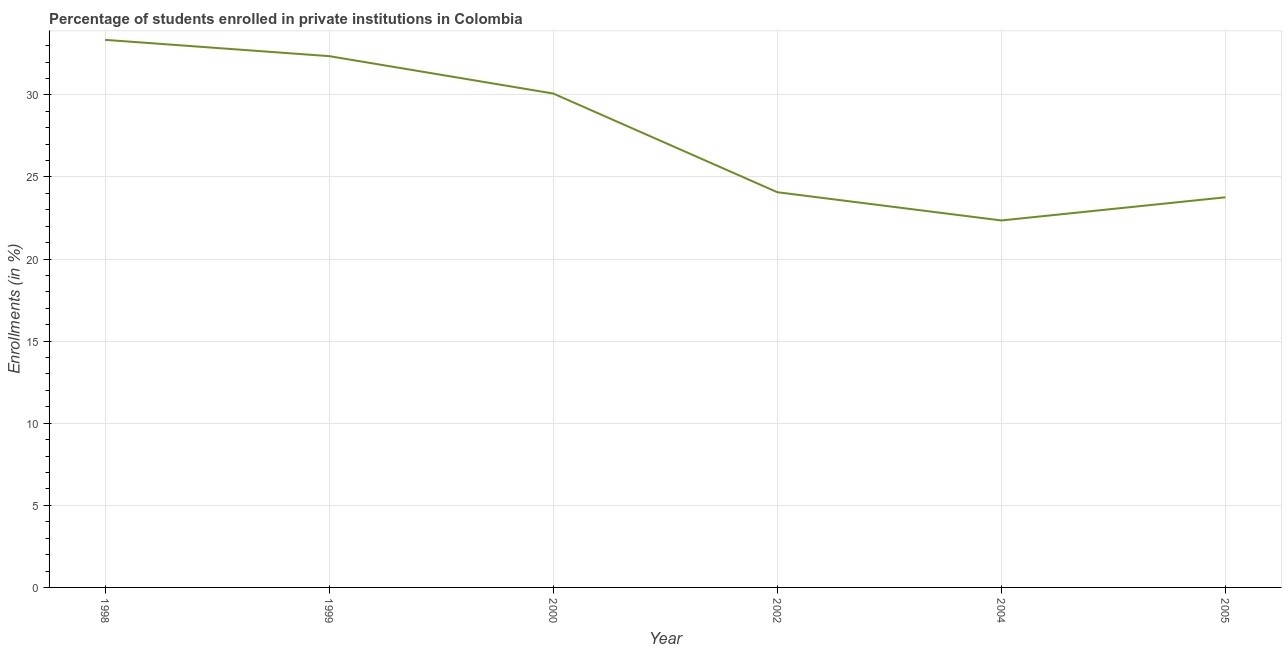What is the enrollments in private institutions in 2005?
Provide a succinct answer. 23.76. Across all years, what is the maximum enrollments in private institutions?
Your answer should be compact. 33.35. Across all years, what is the minimum enrollments in private institutions?
Offer a terse response. 22.35. In which year was the enrollments in private institutions maximum?
Make the answer very short. 1998. In which year was the enrollments in private institutions minimum?
Provide a short and direct response. 2004. What is the sum of the enrollments in private institutions?
Your answer should be compact. 165.98. What is the difference between the enrollments in private institutions in 2000 and 2005?
Provide a short and direct response. 6.32. What is the average enrollments in private institutions per year?
Offer a very short reply. 27.66. What is the median enrollments in private institutions?
Your answer should be compact. 27.08. What is the ratio of the enrollments in private institutions in 1998 to that in 2005?
Provide a succinct answer. 1.4. Is the enrollments in private institutions in 1998 less than that in 2000?
Your answer should be compact. No. What is the difference between the highest and the second highest enrollments in private institutions?
Provide a succinct answer. 0.99. Is the sum of the enrollments in private institutions in 1998 and 2005 greater than the maximum enrollments in private institutions across all years?
Your answer should be compact. Yes. What is the difference between the highest and the lowest enrollments in private institutions?
Your answer should be compact. 11. What is the title of the graph?
Keep it short and to the point. Percentage of students enrolled in private institutions in Colombia. What is the label or title of the Y-axis?
Keep it short and to the point. Enrollments (in %). What is the Enrollments (in %) of 1998?
Make the answer very short. 33.35. What is the Enrollments (in %) in 1999?
Your answer should be very brief. 32.36. What is the Enrollments (in %) in 2000?
Ensure brevity in your answer.  30.08. What is the Enrollments (in %) of 2002?
Ensure brevity in your answer.  24.07. What is the Enrollments (in %) in 2004?
Give a very brief answer. 22.35. What is the Enrollments (in %) in 2005?
Keep it short and to the point. 23.76. What is the difference between the Enrollments (in %) in 1998 and 1999?
Give a very brief answer. 0.99. What is the difference between the Enrollments (in %) in 1998 and 2000?
Provide a succinct answer. 3.27. What is the difference between the Enrollments (in %) in 1998 and 2002?
Offer a very short reply. 9.28. What is the difference between the Enrollments (in %) in 1998 and 2004?
Your answer should be compact. 11. What is the difference between the Enrollments (in %) in 1998 and 2005?
Your answer should be very brief. 9.59. What is the difference between the Enrollments (in %) in 1999 and 2000?
Give a very brief answer. 2.28. What is the difference between the Enrollments (in %) in 1999 and 2002?
Ensure brevity in your answer.  8.29. What is the difference between the Enrollments (in %) in 1999 and 2004?
Offer a terse response. 10.01. What is the difference between the Enrollments (in %) in 1999 and 2005?
Your answer should be very brief. 8.6. What is the difference between the Enrollments (in %) in 2000 and 2002?
Your response must be concise. 6.01. What is the difference between the Enrollments (in %) in 2000 and 2004?
Offer a terse response. 7.73. What is the difference between the Enrollments (in %) in 2000 and 2005?
Your answer should be compact. 6.32. What is the difference between the Enrollments (in %) in 2002 and 2004?
Provide a succinct answer. 1.72. What is the difference between the Enrollments (in %) in 2002 and 2005?
Make the answer very short. 0.31. What is the difference between the Enrollments (in %) in 2004 and 2005?
Offer a very short reply. -1.41. What is the ratio of the Enrollments (in %) in 1998 to that in 1999?
Give a very brief answer. 1.03. What is the ratio of the Enrollments (in %) in 1998 to that in 2000?
Ensure brevity in your answer.  1.11. What is the ratio of the Enrollments (in %) in 1998 to that in 2002?
Your answer should be very brief. 1.39. What is the ratio of the Enrollments (in %) in 1998 to that in 2004?
Ensure brevity in your answer.  1.49. What is the ratio of the Enrollments (in %) in 1998 to that in 2005?
Provide a succinct answer. 1.4. What is the ratio of the Enrollments (in %) in 1999 to that in 2000?
Offer a very short reply. 1.08. What is the ratio of the Enrollments (in %) in 1999 to that in 2002?
Offer a very short reply. 1.34. What is the ratio of the Enrollments (in %) in 1999 to that in 2004?
Your response must be concise. 1.45. What is the ratio of the Enrollments (in %) in 1999 to that in 2005?
Your response must be concise. 1.36. What is the ratio of the Enrollments (in %) in 2000 to that in 2004?
Your answer should be very brief. 1.35. What is the ratio of the Enrollments (in %) in 2000 to that in 2005?
Make the answer very short. 1.27. What is the ratio of the Enrollments (in %) in 2002 to that in 2004?
Provide a succinct answer. 1.08. What is the ratio of the Enrollments (in %) in 2002 to that in 2005?
Offer a terse response. 1.01. What is the ratio of the Enrollments (in %) in 2004 to that in 2005?
Offer a terse response. 0.94. 